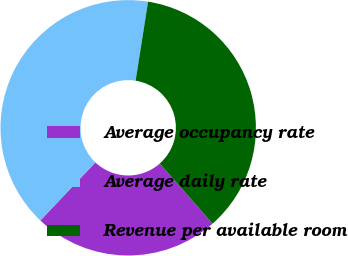Convert chart to OTSL. <chart><loc_0><loc_0><loc_500><loc_500><pie_chart><fcel>Average occupancy rate<fcel>Average daily rate<fcel>Revenue per available room<nl><fcel>23.57%<fcel>40.41%<fcel>36.02%<nl></chart> 